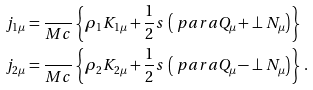<formula> <loc_0><loc_0><loc_500><loc_500>j _ { 1 \mu } & = \frac { } { M c } \left \{ \rho _ { 1 } K _ { 1 \mu } + \frac { 1 } { 2 } s \, \left ( \ p a r a Q _ { \mu } + \perp N _ { \mu } \right ) \right \} \\ j _ { 2 \mu } & = \frac { } { M c } \left \{ \rho _ { 2 } K _ { 2 \mu } + \frac { 1 } { 2 } s \, \left ( \ p a r a Q _ { \mu } - \perp N _ { \mu } \right ) \right \} \, .</formula> 